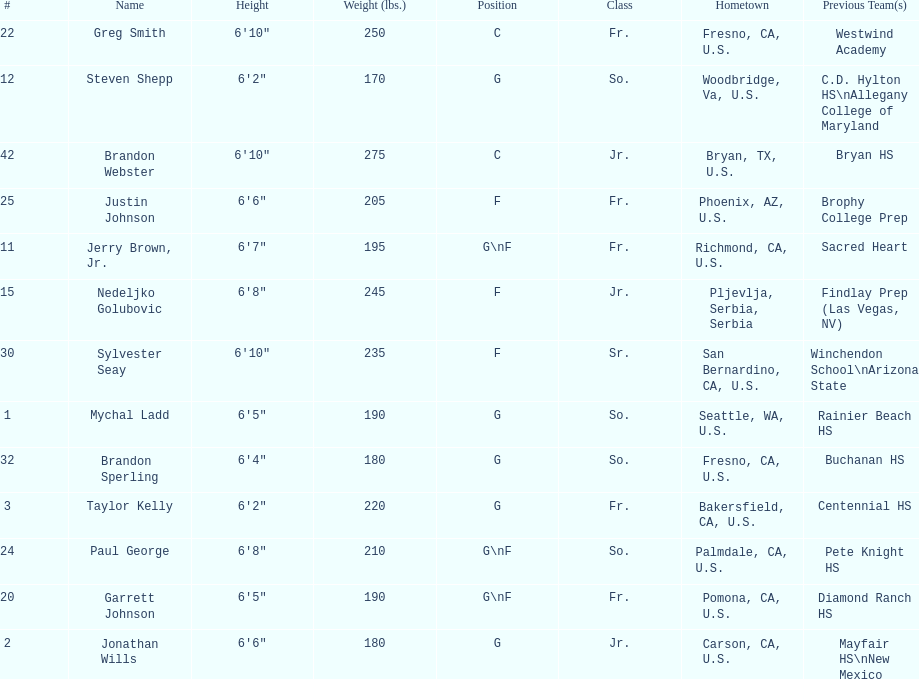What is the number of players who weight over 200 pounds? 7. 